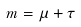Convert formula to latex. <formula><loc_0><loc_0><loc_500><loc_500>m = \mu + \tau</formula> 